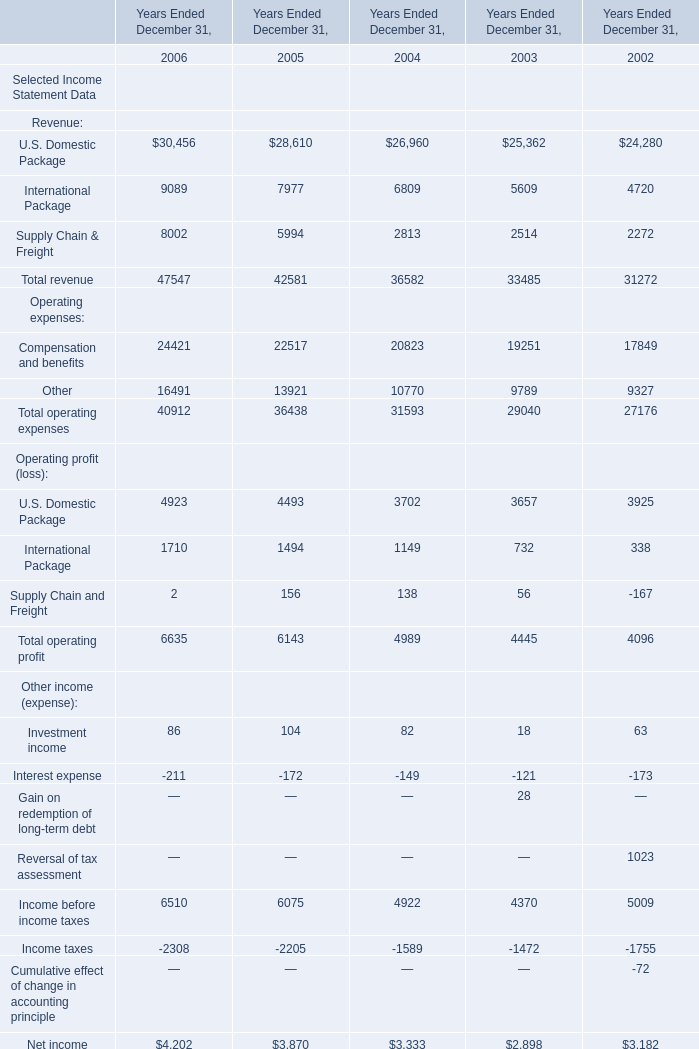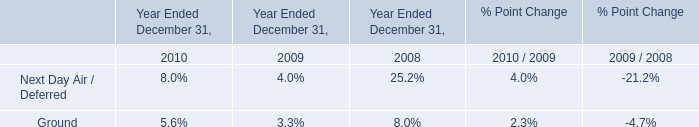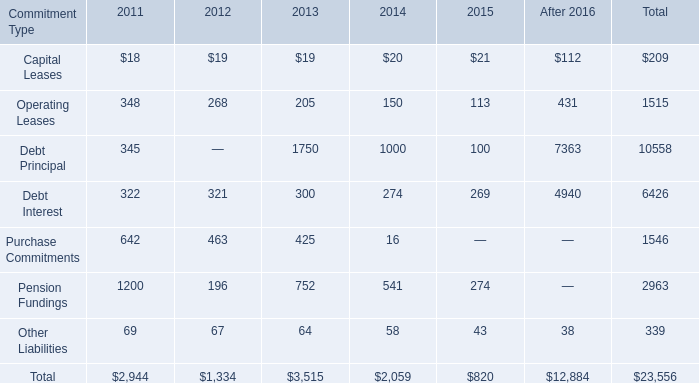what percentage of contractual obligations and commitments in total are debt principal and debt interest? 
Computations: ((10558 + 6426) / 23556)
Answer: 0.72101. 